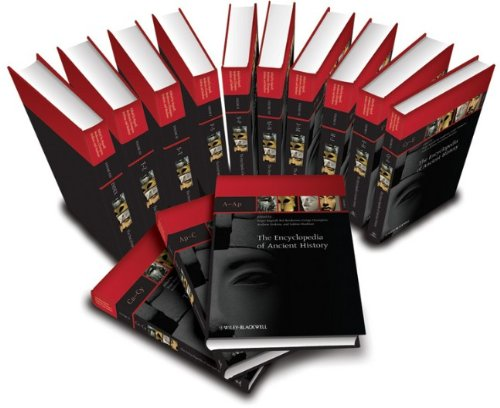What is the genre of this book? The genre of 'The Encyclopedia of Ancient History' is 'Reference'. It is designed to serve as a comprehensive guide and authoritative resource on ancient history. 